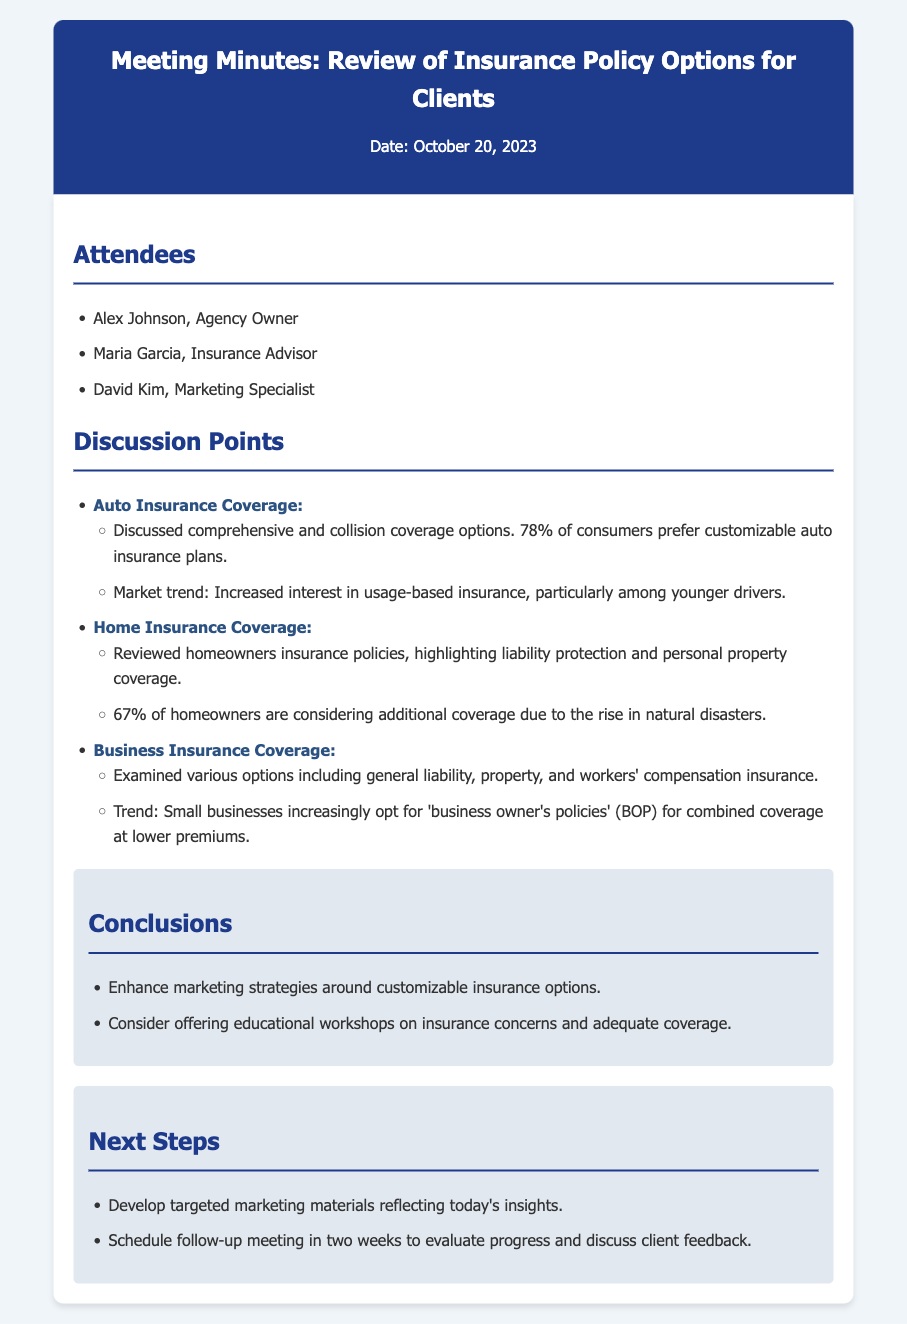What date was the meeting held? The meeting date is specified in the document header.
Answer: October 20, 2023 Who is the agency owner? The name of the agency owner is listed under the attendees section.
Answer: Alex Johnson What percentage of consumers prefer customizable auto insurance plans? The percentage is mentioned in the discussion on auto insurance coverage.
Answer: 78% What is one major trend noted for business insurance? The trend is described in the section about business insurance coverage.
Answer: 'business owner's policies' (BOP) How many attendees are listed in the document? The number of attendees can be counted from the attendees section of the minutes.
Answer: 3 What is recommended to enhance marketing strategies? The recommendations are outlined in the conclusions section.
Answer: customizable insurance options When is the follow-up meeting scheduled? The timing for the follow-up meeting is mentioned in the next steps section.
Answer: in two weeks What coverage is being considered by 67% of homeowners? The specific coverage is highlighted in the home insurance coverage discussion.
Answer: additional coverage Which insurance type is targeted at younger drivers? The specific insurance type is indicated in the auto insurance coverage discussion.
Answer: usage-based insurance 